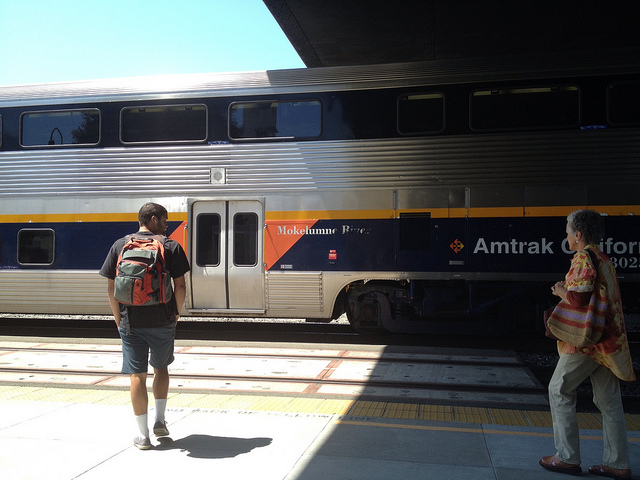<image>What color is the boy's coat? The boy is not wearing a coat in the image. However, some answers suggest it might be black or blue. What color is the boy's coat? It is ambiguous what color is the boy's coat. There are answers like 'black', 'blue', 'no coat', "boy isn't wearing coat" and 'none'. 